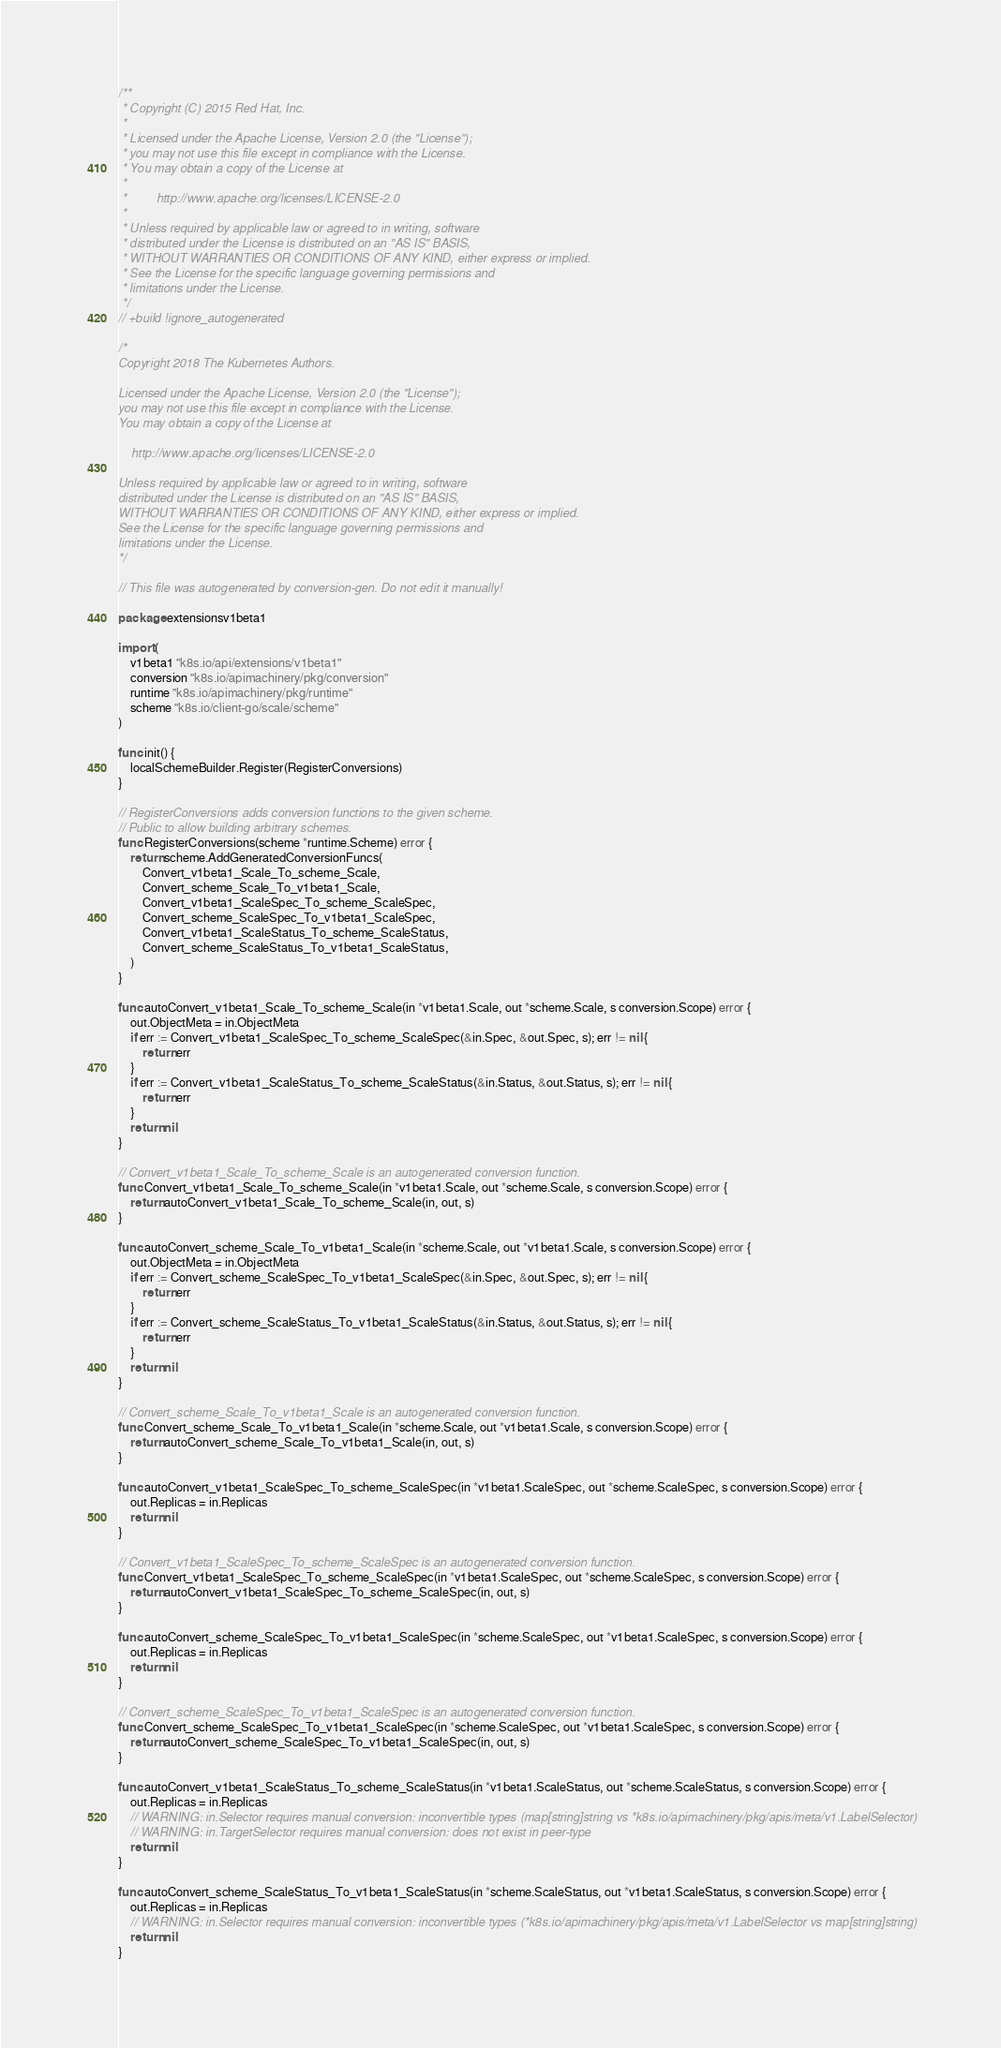<code> <loc_0><loc_0><loc_500><loc_500><_Go_>/**
 * Copyright (C) 2015 Red Hat, Inc.
 *
 * Licensed under the Apache License, Version 2.0 (the "License");
 * you may not use this file except in compliance with the License.
 * You may obtain a copy of the License at
 *
 *         http://www.apache.org/licenses/LICENSE-2.0
 *
 * Unless required by applicable law or agreed to in writing, software
 * distributed under the License is distributed on an "AS IS" BASIS,
 * WITHOUT WARRANTIES OR CONDITIONS OF ANY KIND, either express or implied.
 * See the License for the specific language governing permissions and
 * limitations under the License.
 */
// +build !ignore_autogenerated

/*
Copyright 2018 The Kubernetes Authors.

Licensed under the Apache License, Version 2.0 (the "License");
you may not use this file except in compliance with the License.
You may obtain a copy of the License at

    http://www.apache.org/licenses/LICENSE-2.0

Unless required by applicable law or agreed to in writing, software
distributed under the License is distributed on an "AS IS" BASIS,
WITHOUT WARRANTIES OR CONDITIONS OF ANY KIND, either express or implied.
See the License for the specific language governing permissions and
limitations under the License.
*/

// This file was autogenerated by conversion-gen. Do not edit it manually!

package extensionsv1beta1

import (
	v1beta1 "k8s.io/api/extensions/v1beta1"
	conversion "k8s.io/apimachinery/pkg/conversion"
	runtime "k8s.io/apimachinery/pkg/runtime"
	scheme "k8s.io/client-go/scale/scheme"
)

func init() {
	localSchemeBuilder.Register(RegisterConversions)
}

// RegisterConversions adds conversion functions to the given scheme.
// Public to allow building arbitrary schemes.
func RegisterConversions(scheme *runtime.Scheme) error {
	return scheme.AddGeneratedConversionFuncs(
		Convert_v1beta1_Scale_To_scheme_Scale,
		Convert_scheme_Scale_To_v1beta1_Scale,
		Convert_v1beta1_ScaleSpec_To_scheme_ScaleSpec,
		Convert_scheme_ScaleSpec_To_v1beta1_ScaleSpec,
		Convert_v1beta1_ScaleStatus_To_scheme_ScaleStatus,
		Convert_scheme_ScaleStatus_To_v1beta1_ScaleStatus,
	)
}

func autoConvert_v1beta1_Scale_To_scheme_Scale(in *v1beta1.Scale, out *scheme.Scale, s conversion.Scope) error {
	out.ObjectMeta = in.ObjectMeta
	if err := Convert_v1beta1_ScaleSpec_To_scheme_ScaleSpec(&in.Spec, &out.Spec, s); err != nil {
		return err
	}
	if err := Convert_v1beta1_ScaleStatus_To_scheme_ScaleStatus(&in.Status, &out.Status, s); err != nil {
		return err
	}
	return nil
}

// Convert_v1beta1_Scale_To_scheme_Scale is an autogenerated conversion function.
func Convert_v1beta1_Scale_To_scheme_Scale(in *v1beta1.Scale, out *scheme.Scale, s conversion.Scope) error {
	return autoConvert_v1beta1_Scale_To_scheme_Scale(in, out, s)
}

func autoConvert_scheme_Scale_To_v1beta1_Scale(in *scheme.Scale, out *v1beta1.Scale, s conversion.Scope) error {
	out.ObjectMeta = in.ObjectMeta
	if err := Convert_scheme_ScaleSpec_To_v1beta1_ScaleSpec(&in.Spec, &out.Spec, s); err != nil {
		return err
	}
	if err := Convert_scheme_ScaleStatus_To_v1beta1_ScaleStatus(&in.Status, &out.Status, s); err != nil {
		return err
	}
	return nil
}

// Convert_scheme_Scale_To_v1beta1_Scale is an autogenerated conversion function.
func Convert_scheme_Scale_To_v1beta1_Scale(in *scheme.Scale, out *v1beta1.Scale, s conversion.Scope) error {
	return autoConvert_scheme_Scale_To_v1beta1_Scale(in, out, s)
}

func autoConvert_v1beta1_ScaleSpec_To_scheme_ScaleSpec(in *v1beta1.ScaleSpec, out *scheme.ScaleSpec, s conversion.Scope) error {
	out.Replicas = in.Replicas
	return nil
}

// Convert_v1beta1_ScaleSpec_To_scheme_ScaleSpec is an autogenerated conversion function.
func Convert_v1beta1_ScaleSpec_To_scheme_ScaleSpec(in *v1beta1.ScaleSpec, out *scheme.ScaleSpec, s conversion.Scope) error {
	return autoConvert_v1beta1_ScaleSpec_To_scheme_ScaleSpec(in, out, s)
}

func autoConvert_scheme_ScaleSpec_To_v1beta1_ScaleSpec(in *scheme.ScaleSpec, out *v1beta1.ScaleSpec, s conversion.Scope) error {
	out.Replicas = in.Replicas
	return nil
}

// Convert_scheme_ScaleSpec_To_v1beta1_ScaleSpec is an autogenerated conversion function.
func Convert_scheme_ScaleSpec_To_v1beta1_ScaleSpec(in *scheme.ScaleSpec, out *v1beta1.ScaleSpec, s conversion.Scope) error {
	return autoConvert_scheme_ScaleSpec_To_v1beta1_ScaleSpec(in, out, s)
}

func autoConvert_v1beta1_ScaleStatus_To_scheme_ScaleStatus(in *v1beta1.ScaleStatus, out *scheme.ScaleStatus, s conversion.Scope) error {
	out.Replicas = in.Replicas
	// WARNING: in.Selector requires manual conversion: inconvertible types (map[string]string vs *k8s.io/apimachinery/pkg/apis/meta/v1.LabelSelector)
	// WARNING: in.TargetSelector requires manual conversion: does not exist in peer-type
	return nil
}

func autoConvert_scheme_ScaleStatus_To_v1beta1_ScaleStatus(in *scheme.ScaleStatus, out *v1beta1.ScaleStatus, s conversion.Scope) error {
	out.Replicas = in.Replicas
	// WARNING: in.Selector requires manual conversion: inconvertible types (*k8s.io/apimachinery/pkg/apis/meta/v1.LabelSelector vs map[string]string)
	return nil
}
</code> 